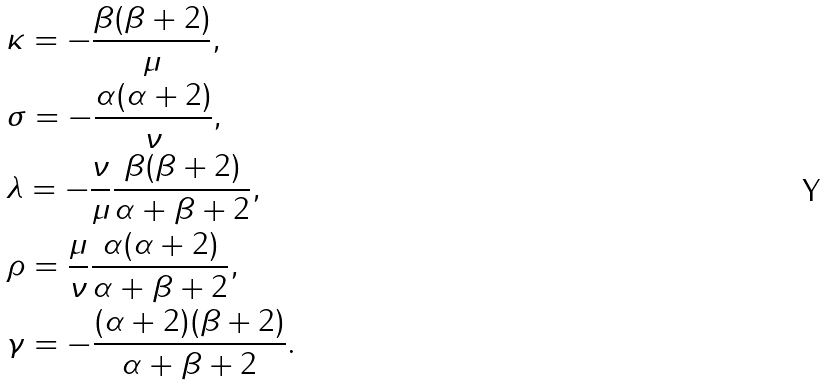<formula> <loc_0><loc_0><loc_500><loc_500>& \kappa = - \frac { \beta ( \beta + 2 ) } { \mu } , \\ & \sigma = - \frac { \alpha ( \alpha + 2 ) } { \nu } , \\ & \lambda = - \frac { \nu } { \mu } \frac { \beta ( \beta + 2 ) } { \alpha + \beta + 2 } , \\ & \rho = \frac { \mu } { \nu } \frac { \alpha ( \alpha + 2 ) } { \alpha + \beta + 2 } , \\ & \gamma = - \frac { ( \alpha + 2 ) ( \beta + 2 ) } { \alpha + \beta + 2 } .</formula> 